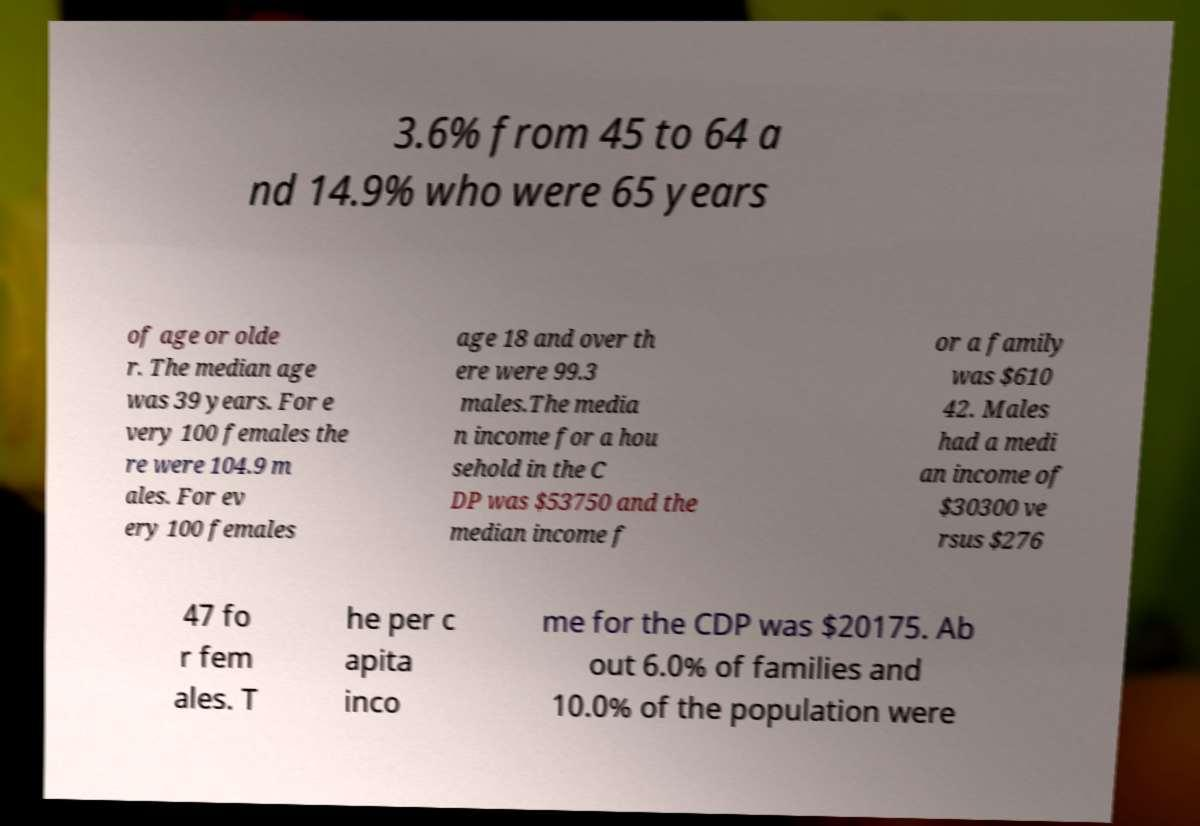For documentation purposes, I need the text within this image transcribed. Could you provide that? 3.6% from 45 to 64 a nd 14.9% who were 65 years of age or olde r. The median age was 39 years. For e very 100 females the re were 104.9 m ales. For ev ery 100 females age 18 and over th ere were 99.3 males.The media n income for a hou sehold in the C DP was $53750 and the median income f or a family was $610 42. Males had a medi an income of $30300 ve rsus $276 47 fo r fem ales. T he per c apita inco me for the CDP was $20175. Ab out 6.0% of families and 10.0% of the population were 